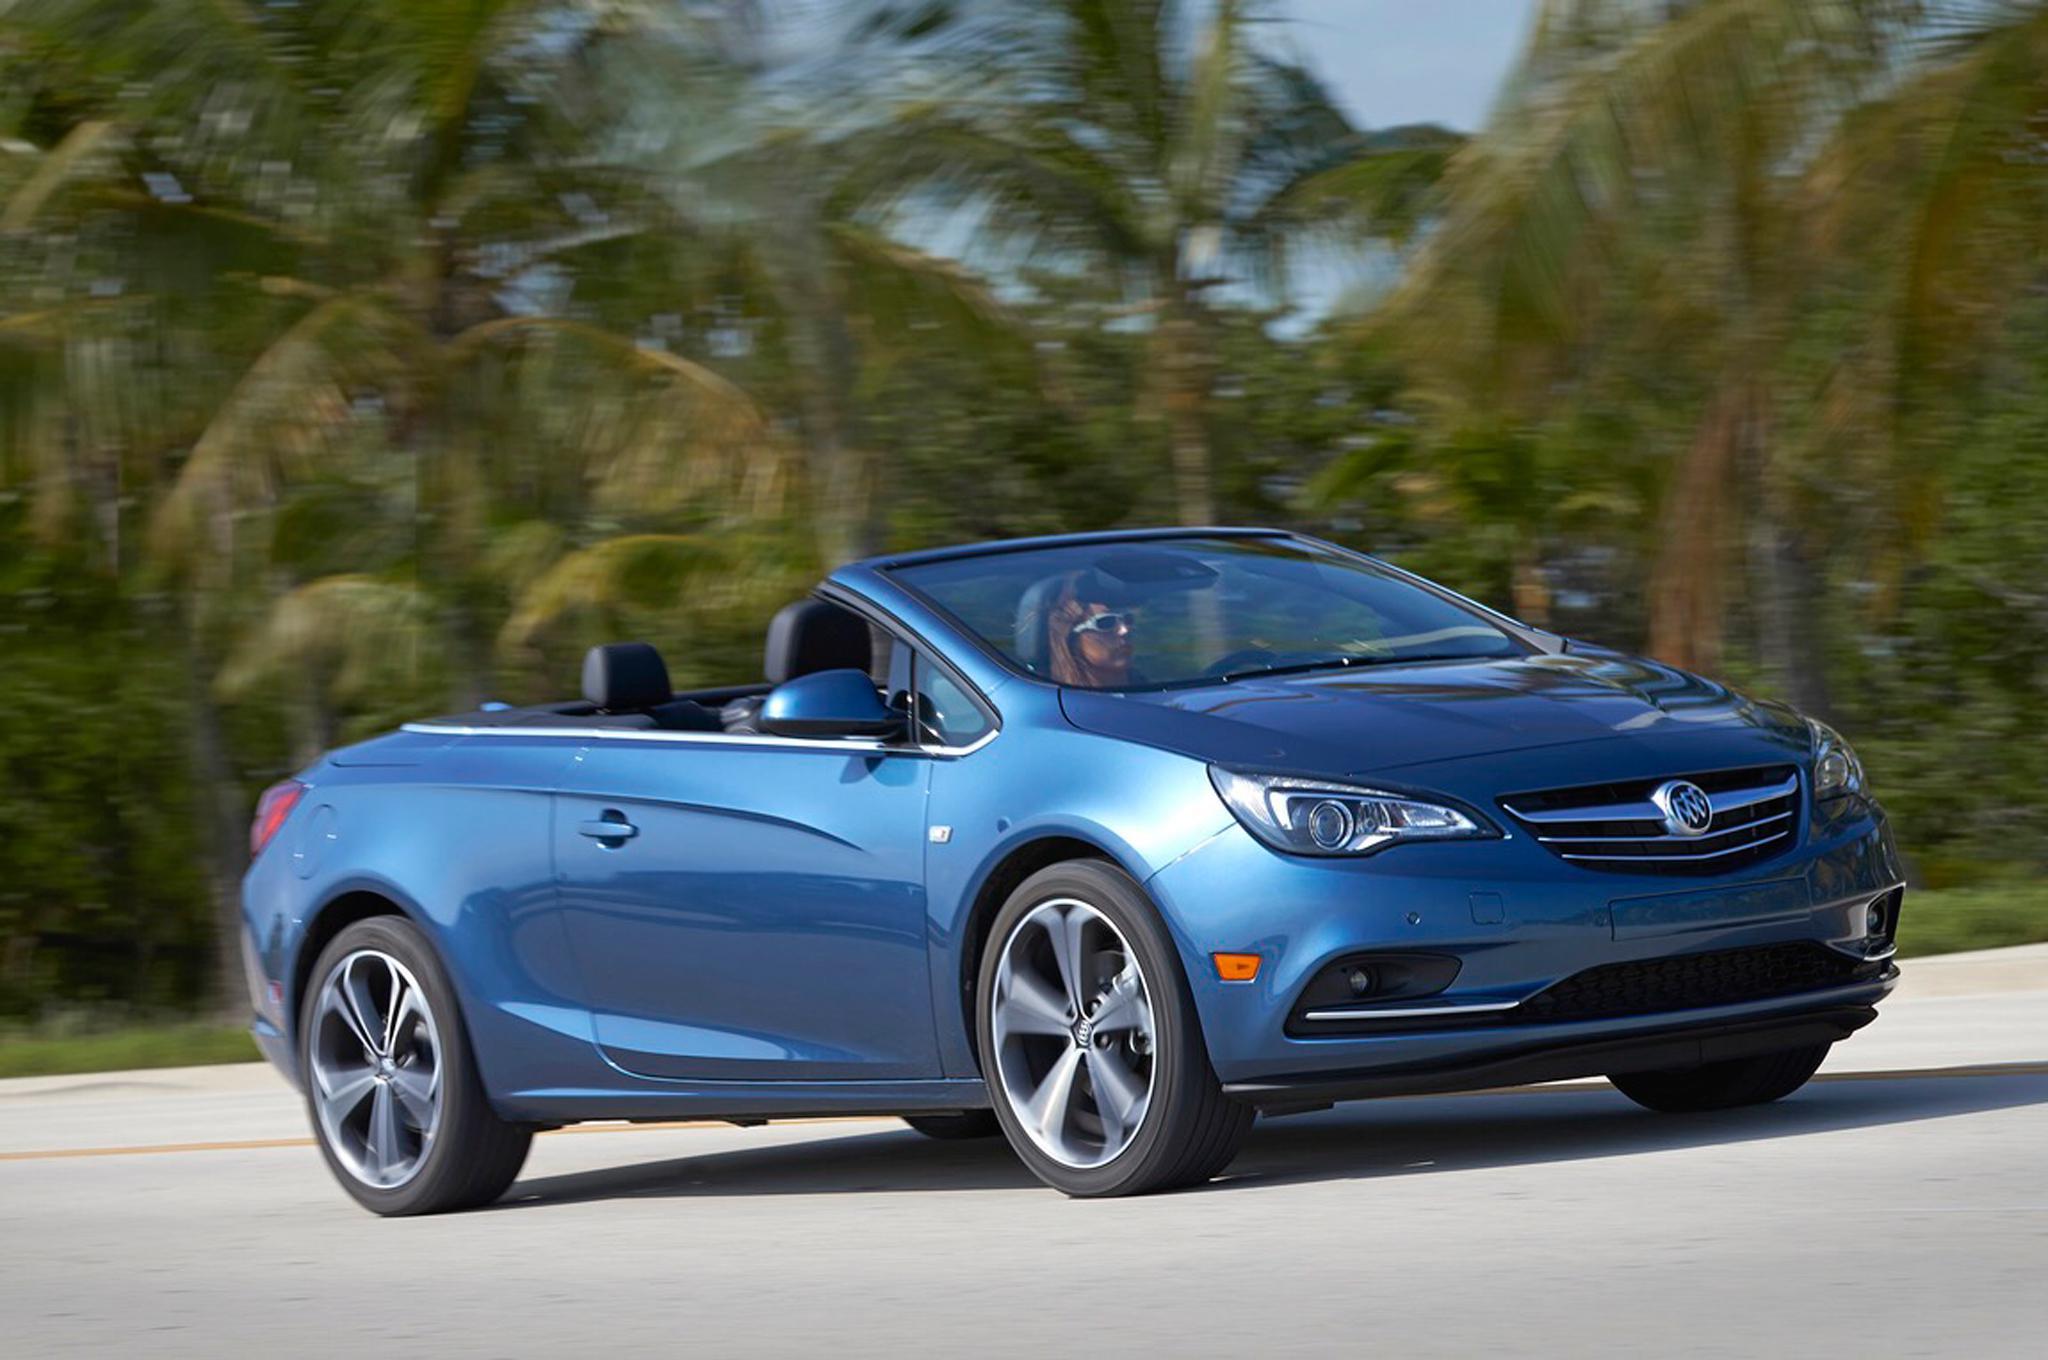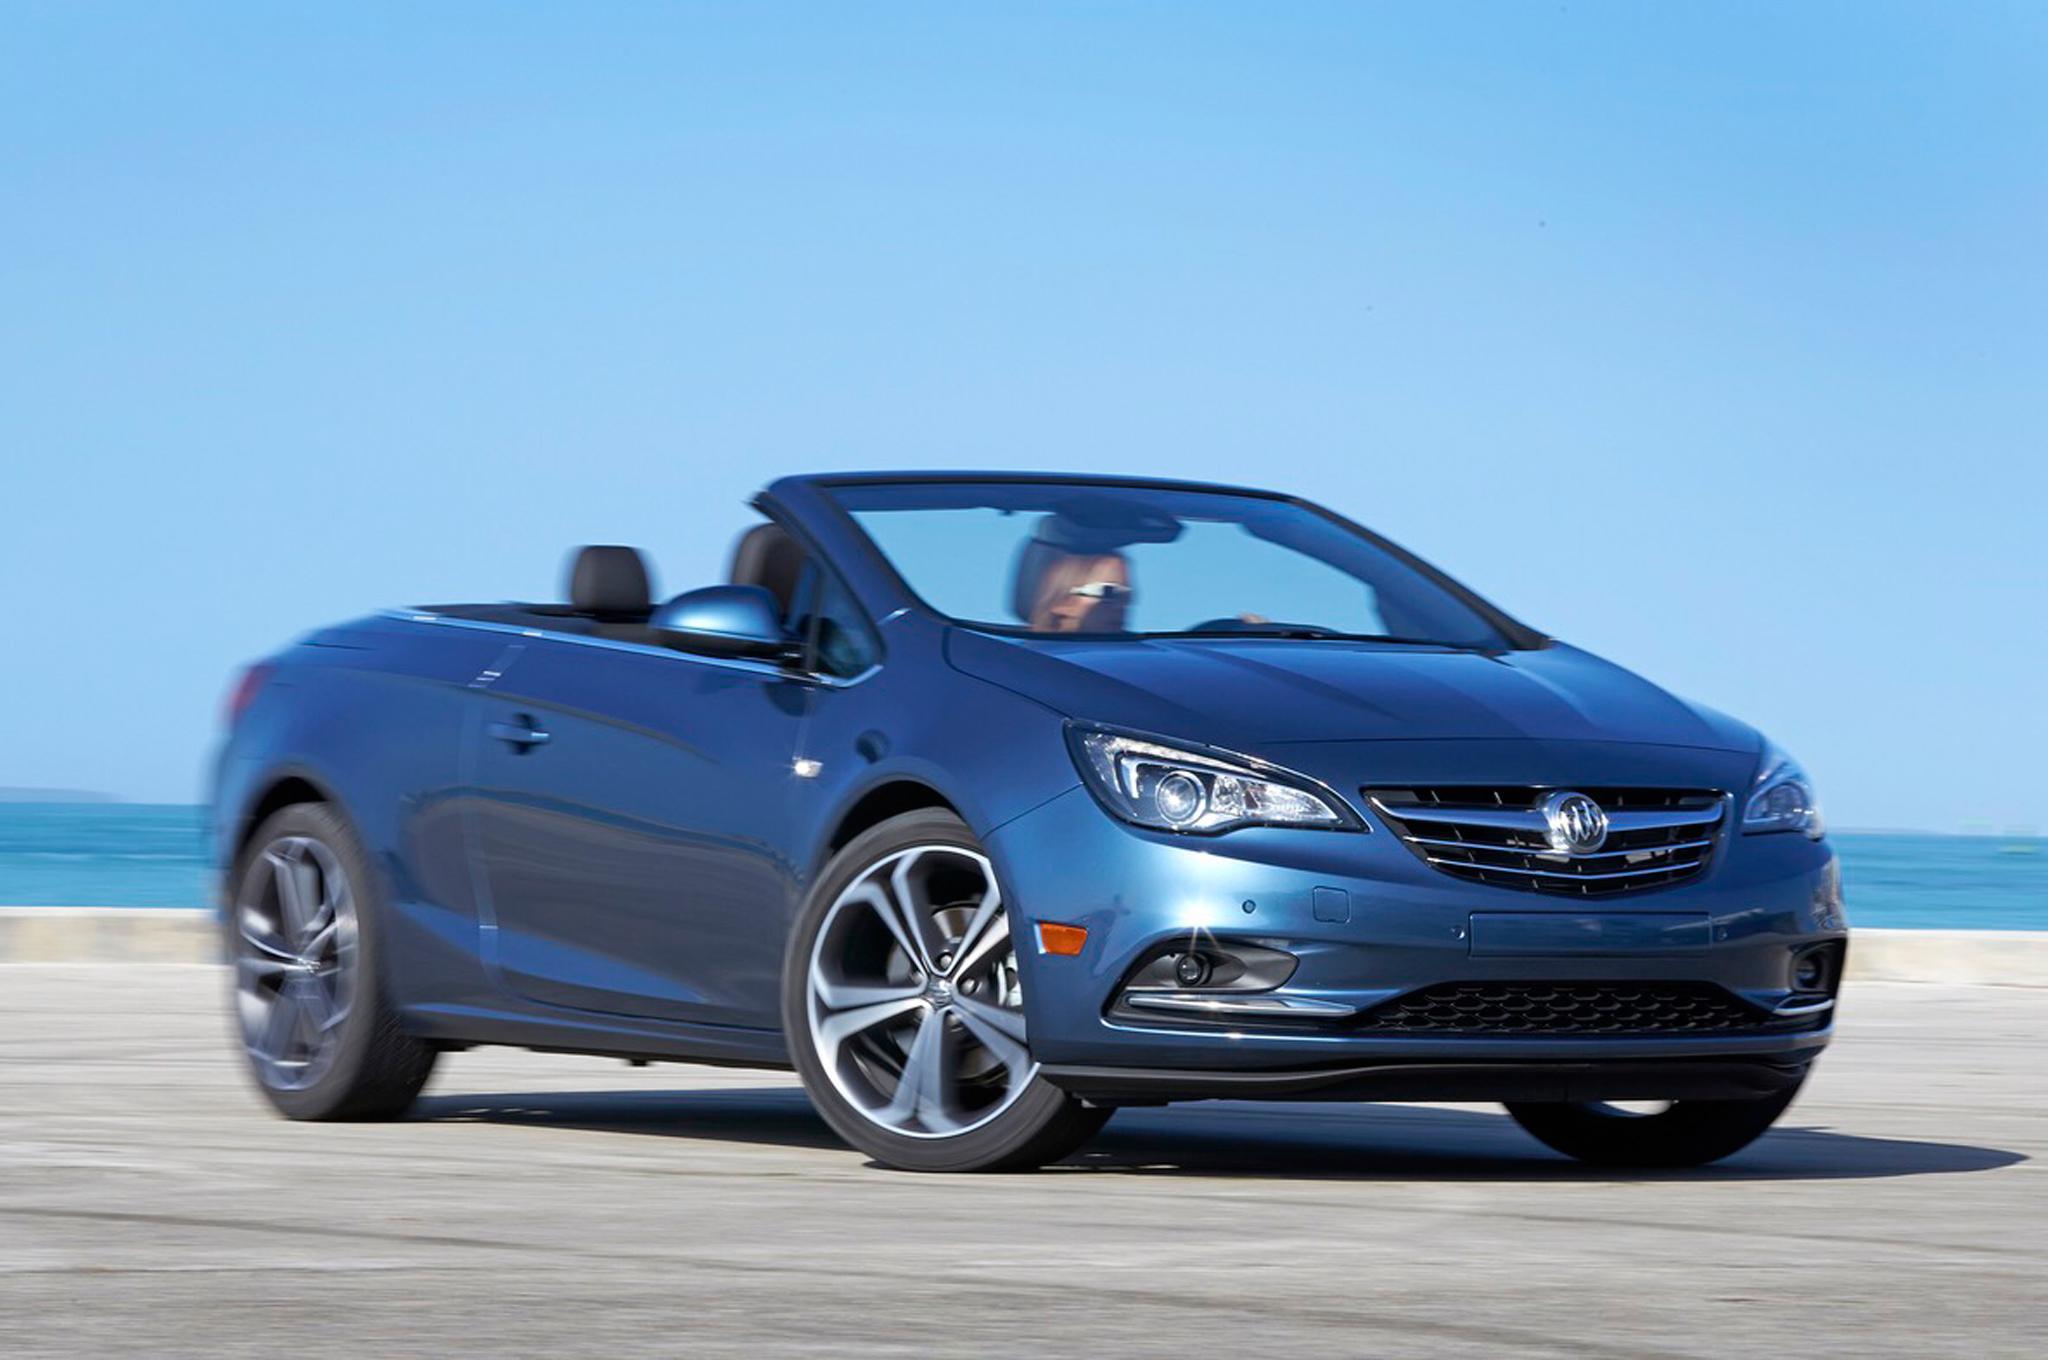The first image is the image on the left, the second image is the image on the right. Given the left and right images, does the statement "There is more than one person in the car in the image on the right." hold true? Answer yes or no. No. The first image is the image on the left, the second image is the image on the right. Evaluate the accuracy of this statement regarding the images: "Each image contains a single blue convertible with its top down, and at least one has a driver.". Is it true? Answer yes or no. Yes. 